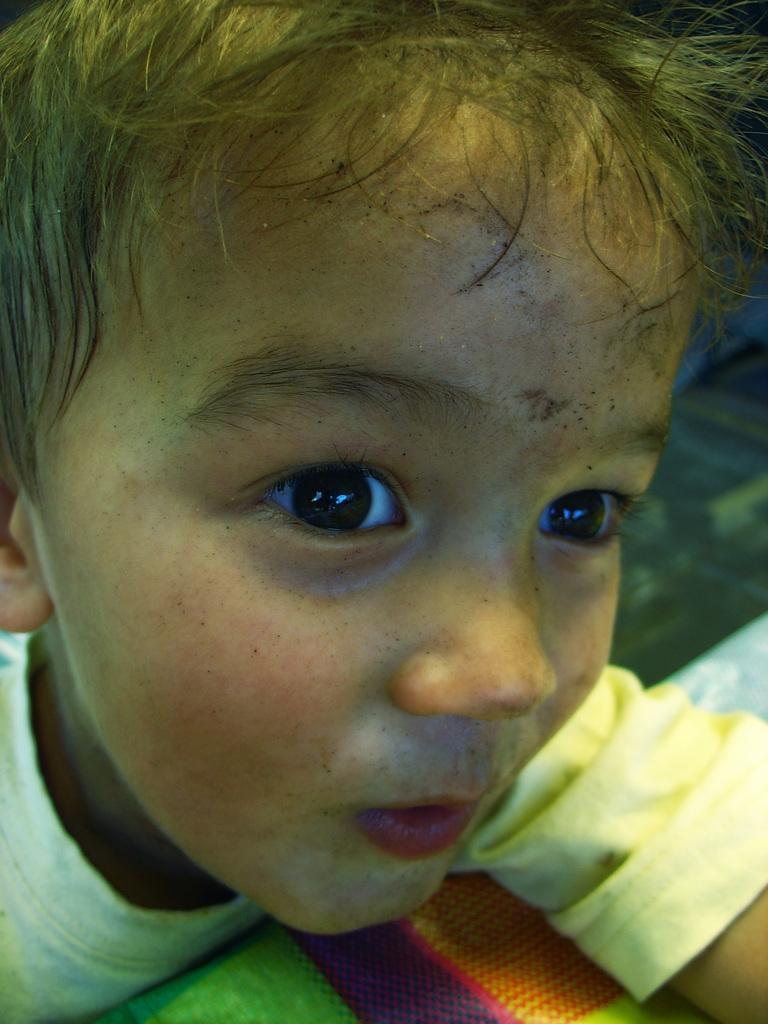Describe this image in one or two sentences. In this picture I can see a boy. The boy is wearing a t-shirt. 